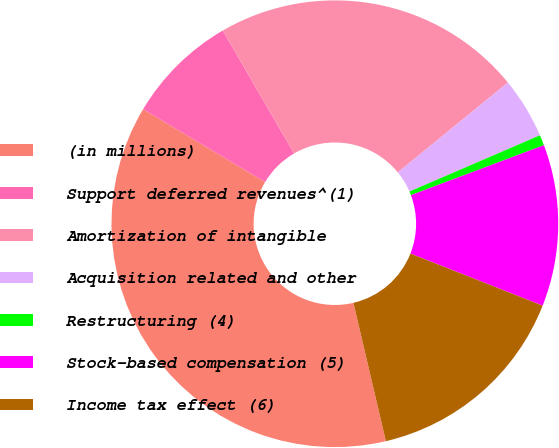Convert chart. <chart><loc_0><loc_0><loc_500><loc_500><pie_chart><fcel>(in millions)<fcel>Support deferred revenues^(1)<fcel>Amortization of intangible<fcel>Acquisition related and other<fcel>Restructuring (4)<fcel>Stock-based compensation (5)<fcel>Income tax effect (6)<nl><fcel>37.24%<fcel>8.06%<fcel>22.48%<fcel>4.41%<fcel>0.76%<fcel>11.7%<fcel>15.35%<nl></chart> 